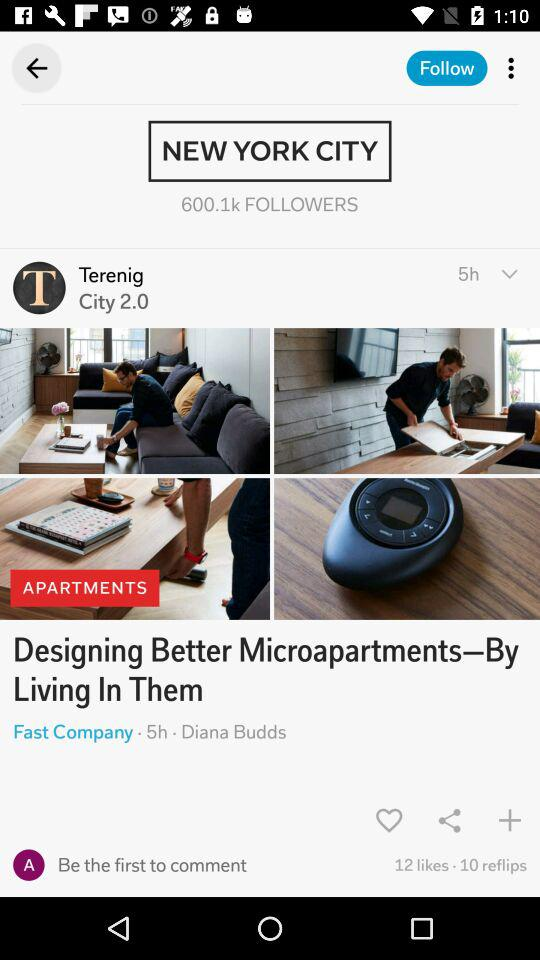How many more likes does the post have than reflips?
Answer the question using a single word or phrase. 2 